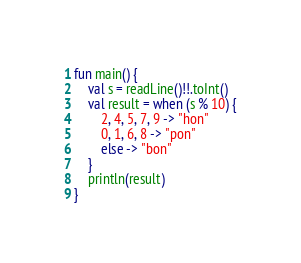<code> <loc_0><loc_0><loc_500><loc_500><_Kotlin_>fun main() {
    val s = readLine()!!.toInt()
    val result = when (s % 10) {
        2, 4, 5, 7, 9 -> "hon"
        0, 1, 6, 8 -> "pon"
        else -> "bon"
    }
    println(result)
}</code> 